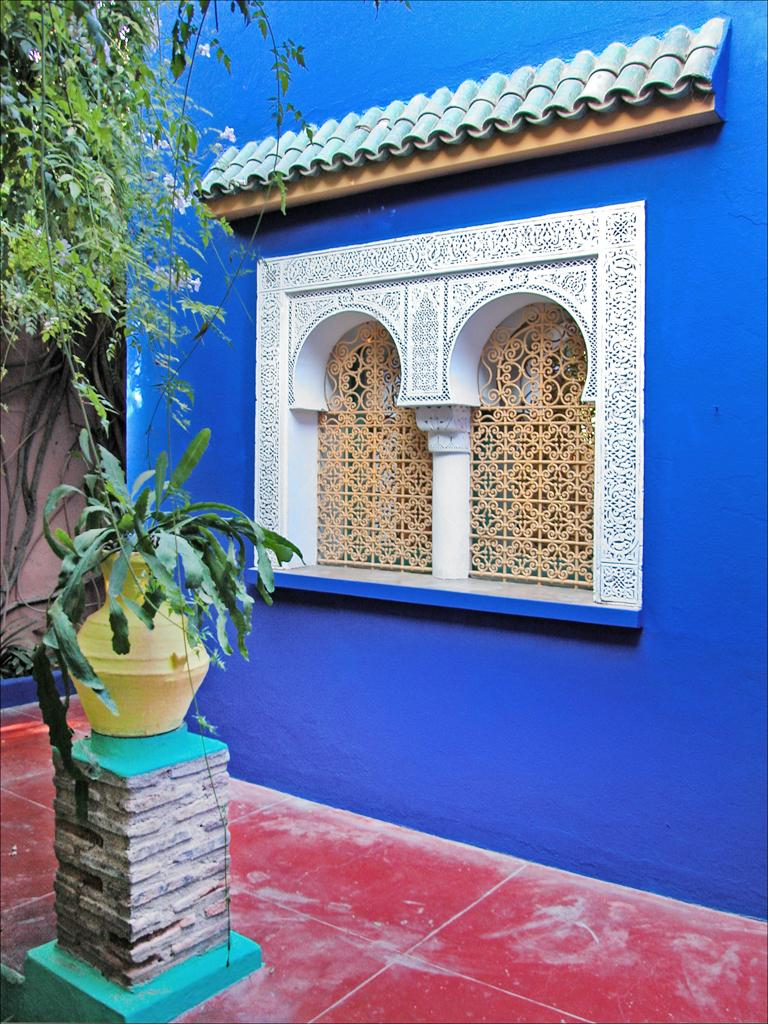What color is the wall in the image? The wall in the image is blue. What types of vegetation can be seen in the image? There are plants, flowers, and a tree in the image. What color is the floor at the bottom of the image? The floor at the bottom of the image is red. What sound can be heard coming from the island in the image? There is no island present in the image, so it is not possible to determine what sound might be heard. 